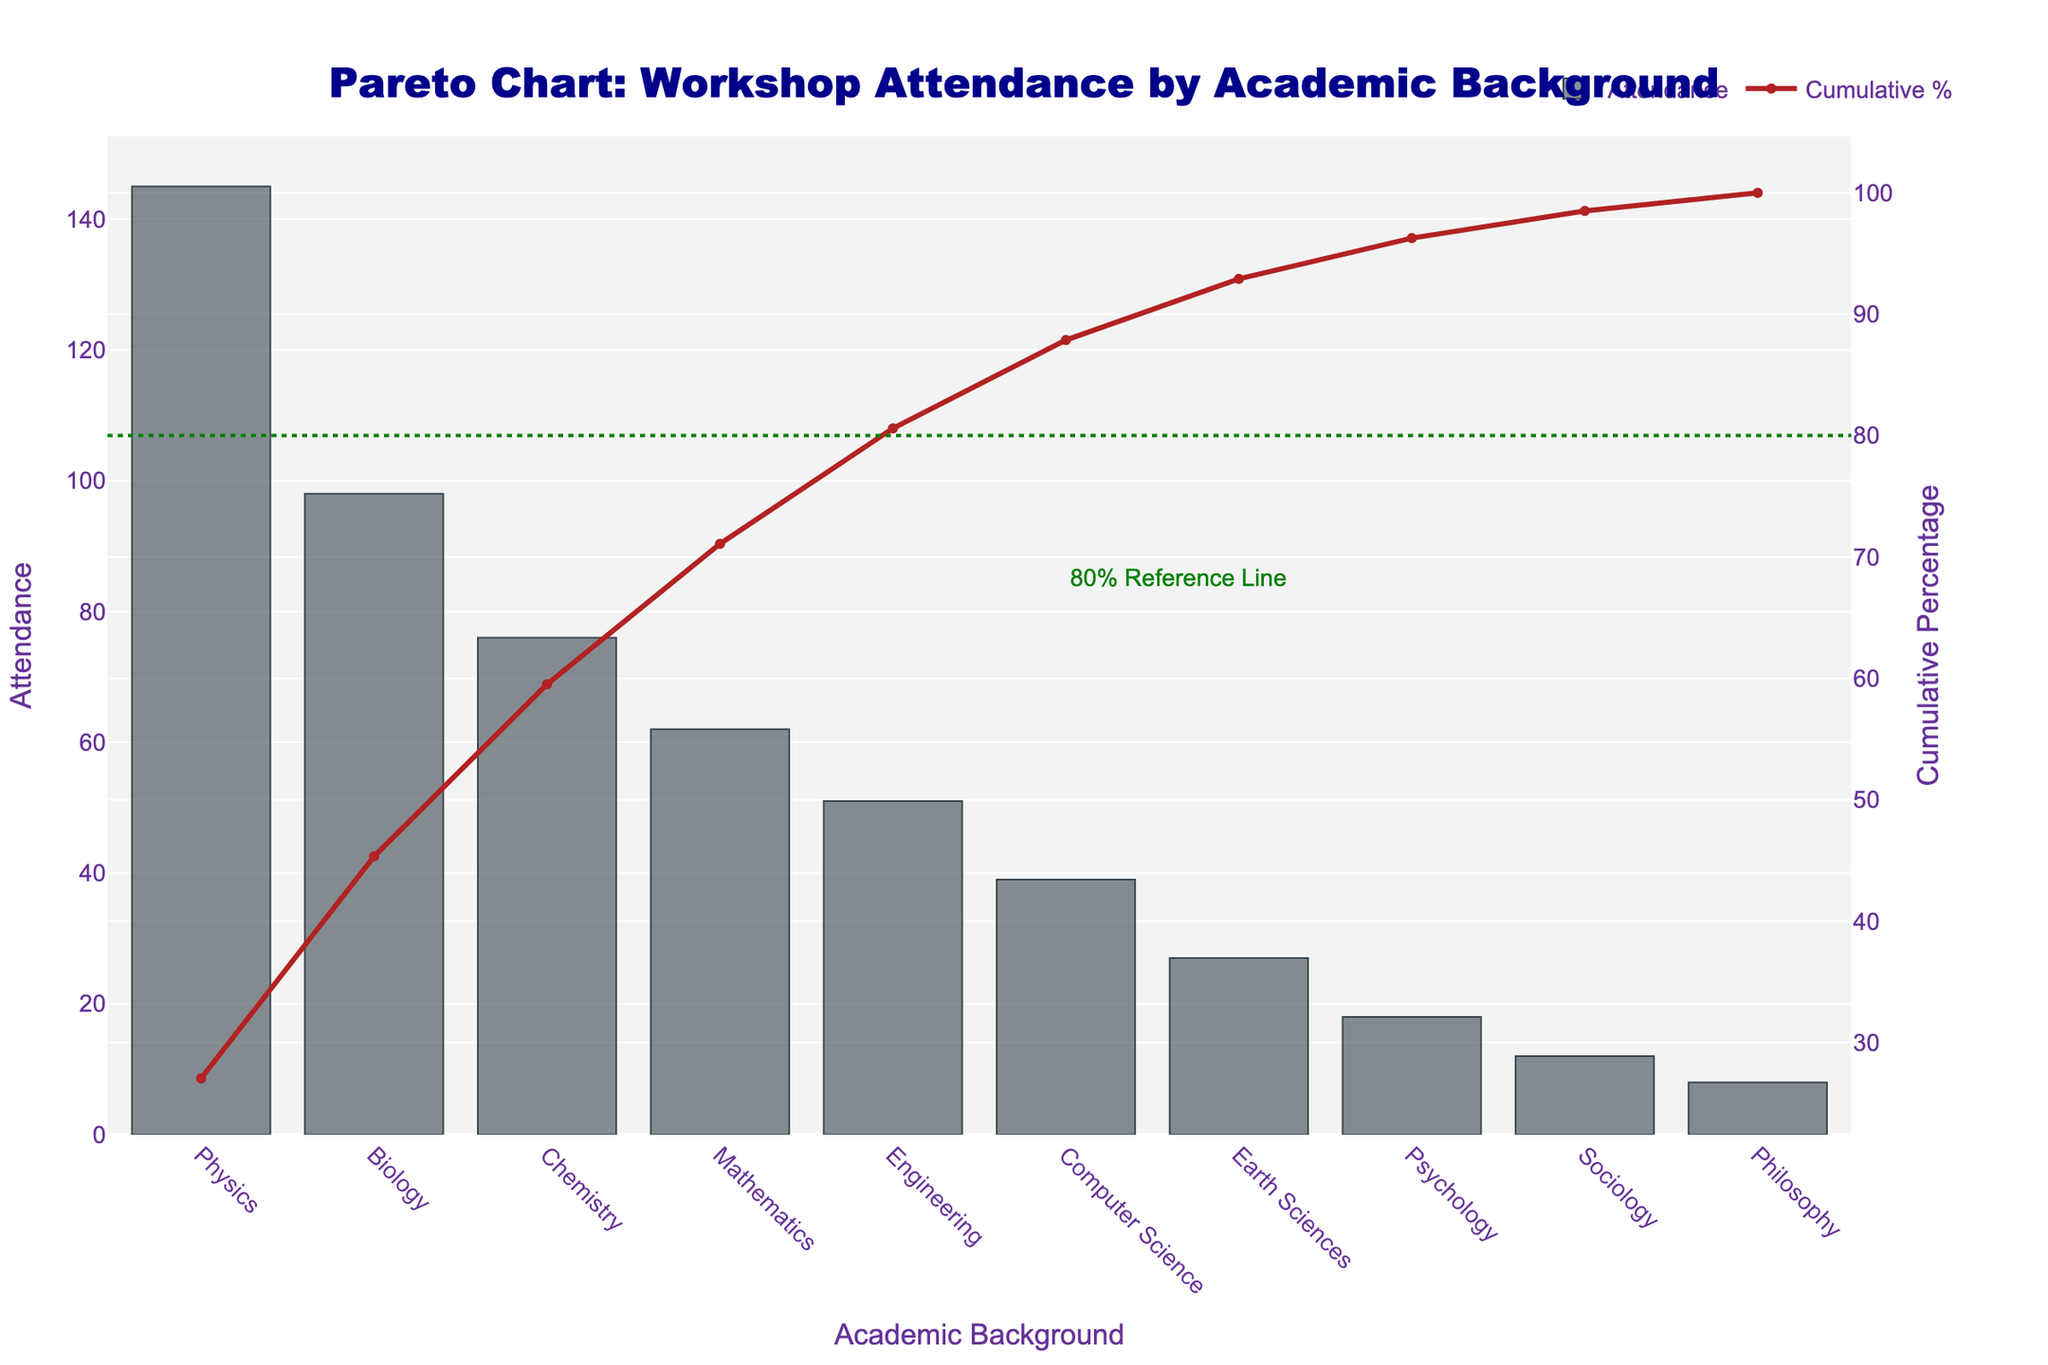What is the title of the figure? The title is typically found at the top of the figure. It is meant to inform the viewer about the primary content of the chart.
Answer: Pareto Chart: Workshop Attendance by Academic Background Which academic background has the highest attendance? Looking at the tallest bar in the figure will show which academic background has the highest attendance.
Answer: Physics What is the cumulative percentage for Computer Science? Locate the point on the line graph corresponding to "Computer Science" and read the y-axis value on the secondary y-axis (cumulative percentage).
Answer: 83.5% How many academic backgrounds have an attendance of over 50? Count the number of bars that exceed the 50 mark on the primary y-axis (attendance).
Answer: Five Which academic background is closest to contributing 80% of the cumulative attendance? Locate where the cumulative percent line crosses the 80% mark on the secondary y-axis and look down to the corresponding academic background.
Answer: Computer Science What is the cumulative percentage up to and including Chemistry? Add the attendance values for Physics, Biology, and Chemistry and divide by the total attendance, then multiply by 100.
Answer: 69.6% Which academic background has the lowest attendance? Look for the shortest bar in the figure to find the academic background with the lowest attendance.
Answer: Philosophy Compare the attendance of Biology and Earth Sciences. Which is higher and by how much? Find the bars corresponding to Biology and Earth Sciences, note their heights (attendance values), then subtract Earth Sciences from Biology's attendance.
Answer: Biology, by 71 What is the purpose of the dotted green line? The chart typically indicates important thresholds with reference lines. The dotted green line is at 80%, a common threshold in Pareto analysis.
Answer: Marks the 80% cumulative percentage threshold How many attendees constitute the top three academic backgrounds? Sum the attendance values for Physics, Biology, and Chemistry.
Answer: 319 